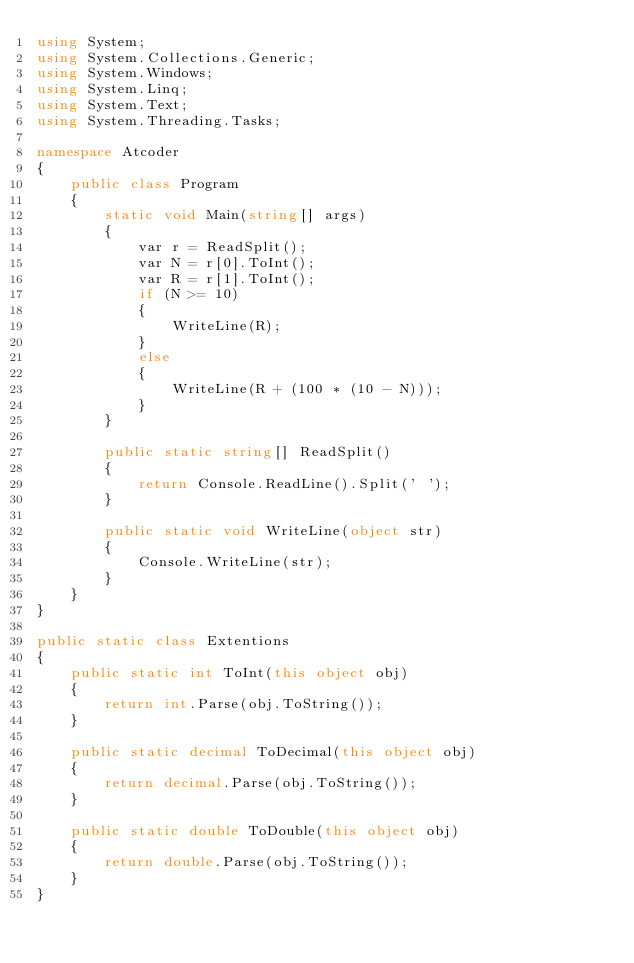Convert code to text. <code><loc_0><loc_0><loc_500><loc_500><_C#_>using System;
using System.Collections.Generic;
using System.Windows;
using System.Linq;
using System.Text;
using System.Threading.Tasks;

namespace Atcoder
{
    public class Program
    {
        static void Main(string[] args)
        {
            var r = ReadSplit();
            var N = r[0].ToInt();
            var R = r[1].ToInt();
            if (N >= 10)
            {
                WriteLine(R);
            }
            else
            {
                WriteLine(R + (100 * (10 - N)));
            }
        }

        public static string[] ReadSplit()
        {
            return Console.ReadLine().Split(' ');
        }

        public static void WriteLine(object str)
        {
            Console.WriteLine(str);
        }
    }
}

public static class Extentions
{
    public static int ToInt(this object obj)
    {
        return int.Parse(obj.ToString());
    }

    public static decimal ToDecimal(this object obj)
    {
        return decimal.Parse(obj.ToString());
    }

    public static double ToDouble(this object obj)
    {
        return double.Parse(obj.ToString());
    }
}

</code> 